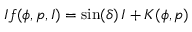Convert formula to latex. <formula><loc_0><loc_0><loc_500><loc_500>I f ( \phi , p , I ) = \sin ( \delta ) \, I + K ( \phi , p )</formula> 